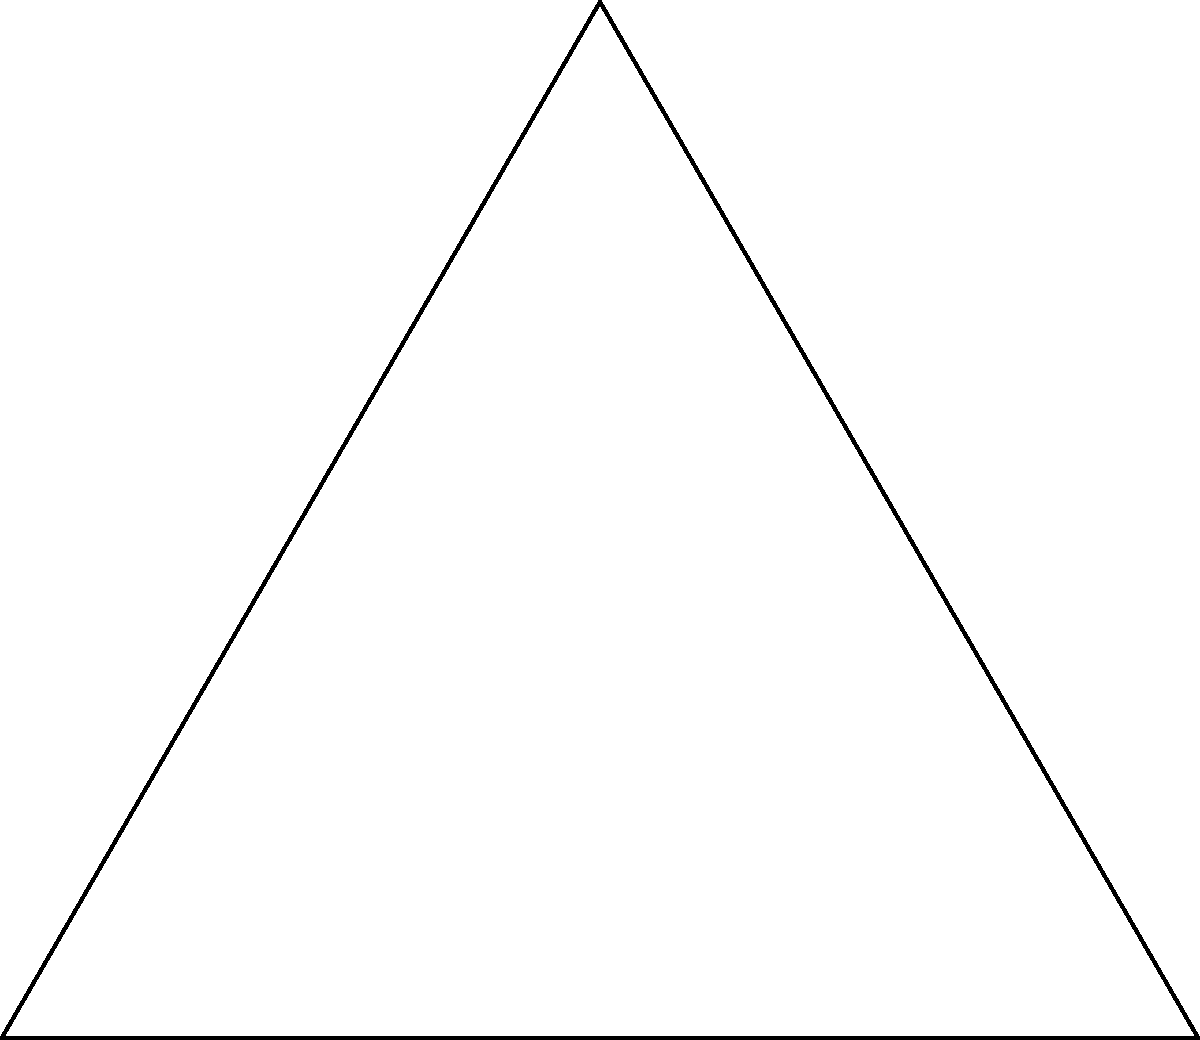In this geometric sculpture, an equilateral triangle is inscribed in a circle. If the side length of the triangle is 2 units, what is the order of the rotational symmetry group of this composition? To determine the order of the rotational symmetry group, we need to follow these steps:

1. Recognize that an equilateral triangle has 3-fold rotational symmetry (120° rotations).

2. A circle has infinite rotational symmetry, but when combined with the triangle, we only consider the symmetries that preserve both shapes.

3. The composition of the triangle inscribed in the circle maintains the 3-fold rotational symmetry of the triangle.

4. Each rotation of 120° about the center of the circle will bring the sculpture back to its original position.

5. The identity transformation (0° rotation) is also included in the symmetry group.

6. Therefore, the rotational symmetry group consists of rotations by 0°, 120°, and 240°.

7. Count the number of elements in this group: there are 3 distinct rotations.

Thus, the order of the rotational symmetry group is 3.
Answer: 3 